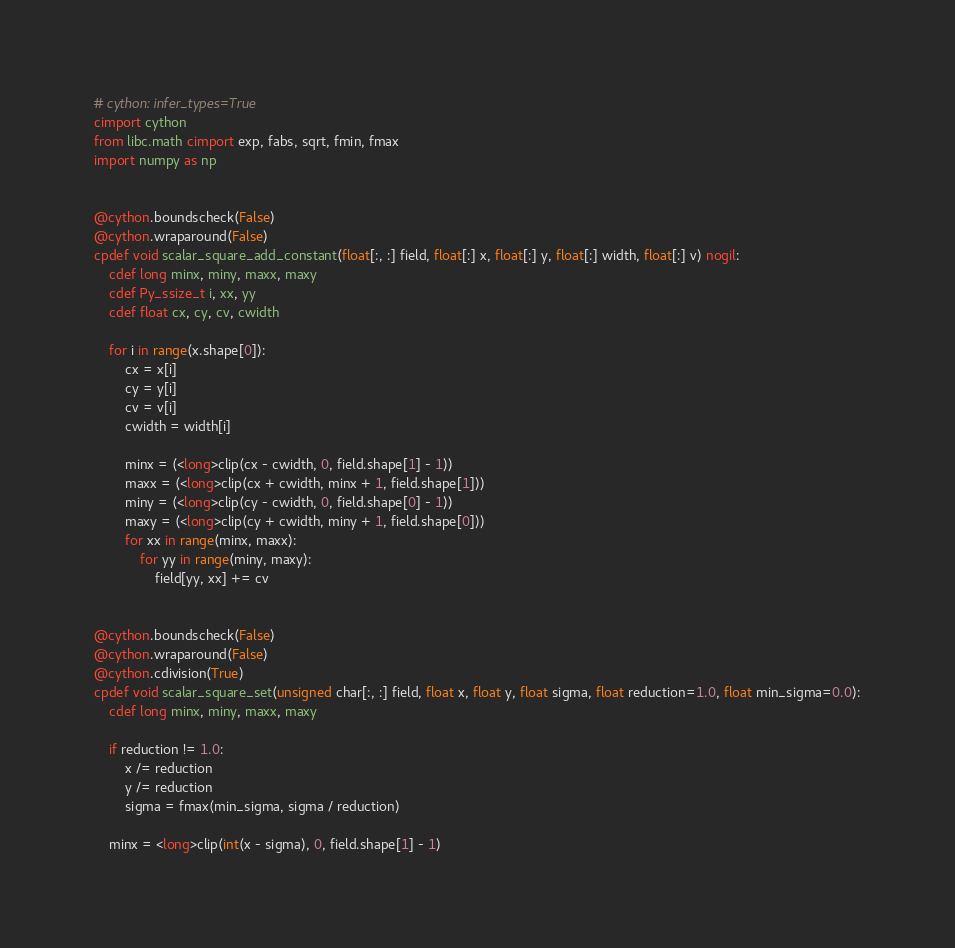Convert code to text. <code><loc_0><loc_0><loc_500><loc_500><_Cython_># cython: infer_types=True
cimport cython
from libc.math cimport exp, fabs, sqrt, fmin, fmax
import numpy as np


@cython.boundscheck(False)
@cython.wraparound(False)
cpdef void scalar_square_add_constant(float[:, :] field, float[:] x, float[:] y, float[:] width, float[:] v) nogil:
    cdef long minx, miny, maxx, maxy
    cdef Py_ssize_t i, xx, yy
    cdef float cx, cy, cv, cwidth

    for i in range(x.shape[0]):
        cx = x[i]
        cy = y[i]
        cv = v[i]
        cwidth = width[i]

        minx = (<long>clip(cx - cwidth, 0, field.shape[1] - 1))
        maxx = (<long>clip(cx + cwidth, minx + 1, field.shape[1]))
        miny = (<long>clip(cy - cwidth, 0, field.shape[0] - 1))
        maxy = (<long>clip(cy + cwidth, miny + 1, field.shape[0]))
        for xx in range(minx, maxx):
            for yy in range(miny, maxy):
                field[yy, xx] += cv


@cython.boundscheck(False)
@cython.wraparound(False)
@cython.cdivision(True)
cpdef void scalar_square_set(unsigned char[:, :] field, float x, float y, float sigma, float reduction=1.0, float min_sigma=0.0):
    cdef long minx, miny, maxx, maxy

    if reduction != 1.0:
        x /= reduction
        y /= reduction
        sigma = fmax(min_sigma, sigma / reduction)

    minx = <long>clip(int(x - sigma), 0, field.shape[1] - 1)</code> 